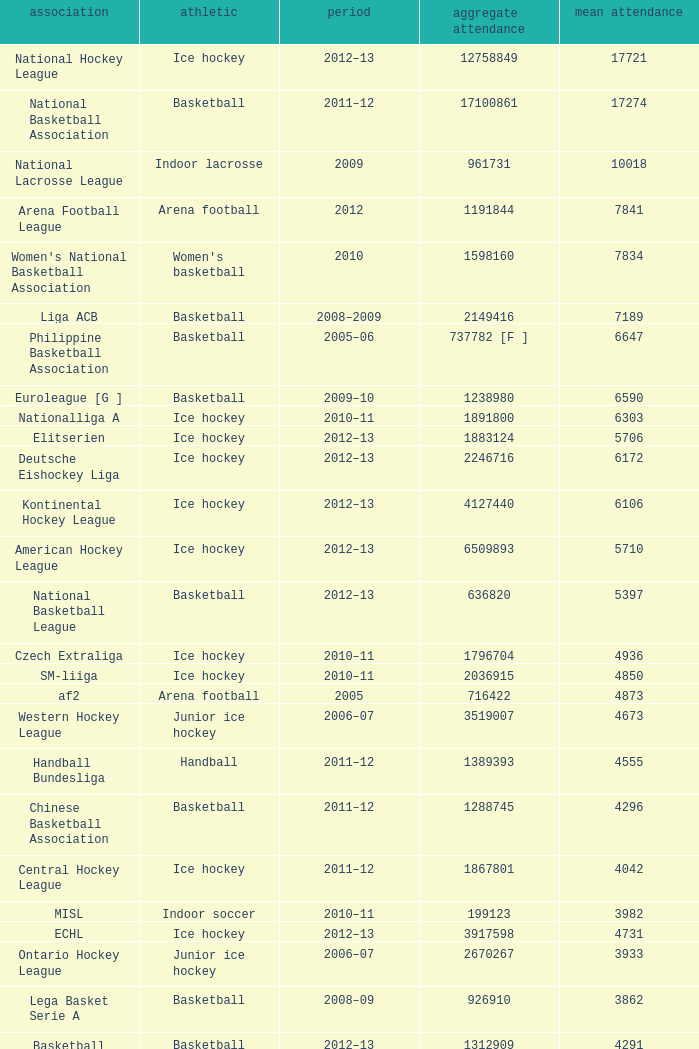What was the highest average attendance in the 2009 season? 10018.0. 